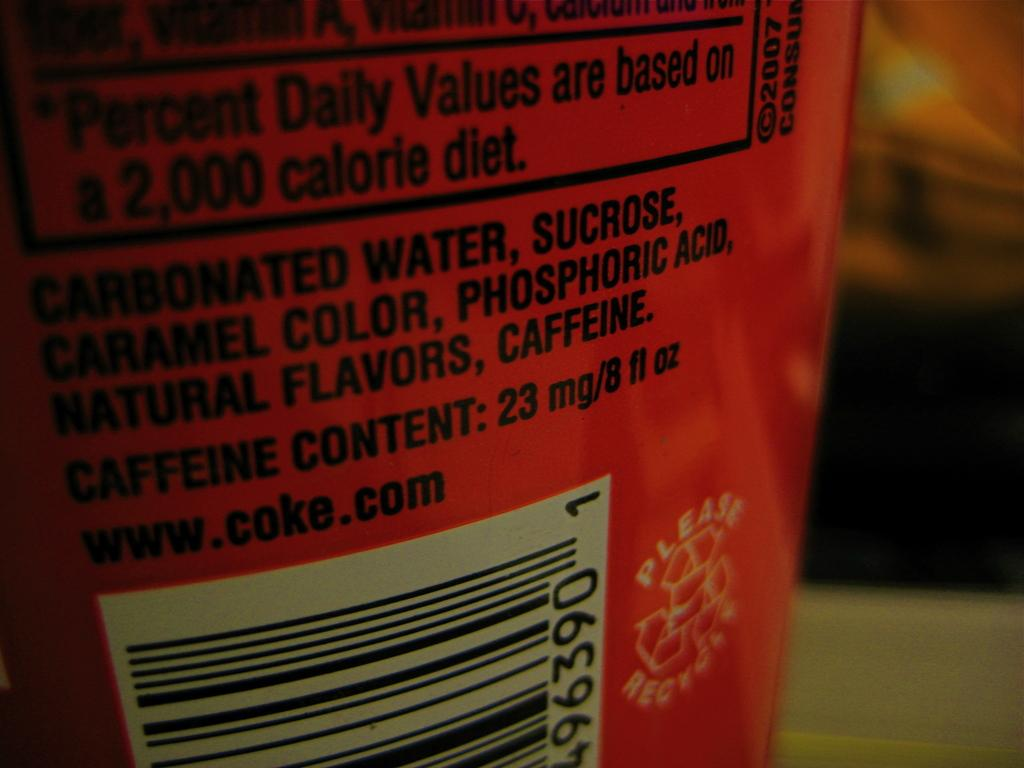<image>
Give a short and clear explanation of the subsequent image. A drink label reads CARBONATED WATER, SUCROSE, CARAMEL COLOR, PHOSPHORIC ACID, NATURAL FLAVORS, CAFFEINE. 